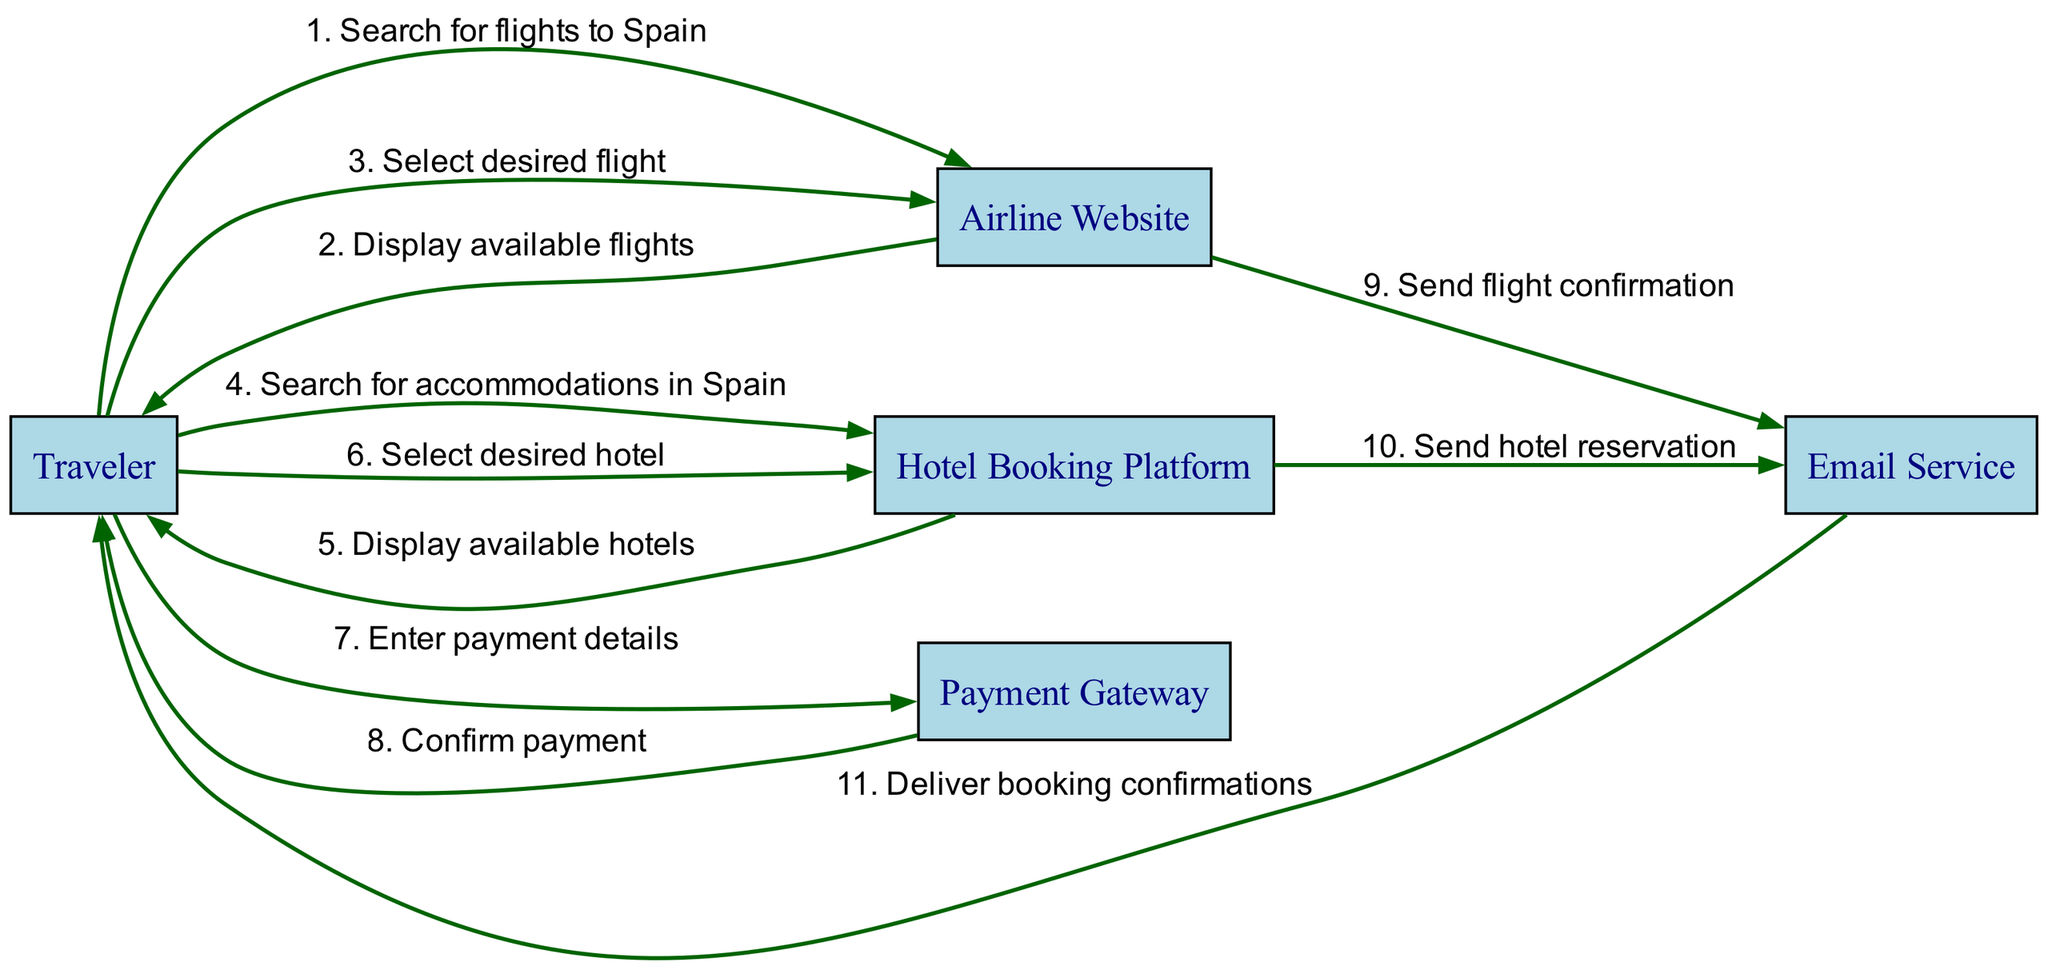What is the first action taken by the Traveler? The first action taken by the Traveler is to search for flights to Spain. This is explicitly indicated as the first action in the sequence diagram, where the Traveler interacts with the Airline Website.
Answer: Search for flights to Spain How many total actors are present in the diagram? The diagram contains a total of five actors: Traveler, Airline Website, Hotel Booking Platform, Payment Gateway, and Email Service. This can be counted directly from the list of actors in the diagram.
Answer: Five What is the final action in the sequence? The final action involves the Email Service delivering the booking confirmations to the Traveler. By following the sequence from start to finish, this action appears last in the process flow.
Answer: Deliver booking confirmations Which actor is responsible for sending the flight confirmation? The actor responsible for sending the flight confirmation is the Email Service. This is shown in the interaction between the Airline Website and the Email Service that follows the payment confirmation.
Answer: Email Service What happens after the Traveler enters payment details? After the Traveler enters payment details, the Payment Gateway confirms the payment. This sequential relationship shows that an action by the Traveler leads directly to a response from the Payment Gateway.
Answer: Confirm payment How many actions occur between the Traveler and the Hotel Booking Platform? There are three actions that occur between the Traveler and the Hotel Booking Platform. The Traveler searches for accommodations, receives available hotels, and selects a hotel. These interactions can be counted from the specified actions concerning the Hotel Booking Platform.
Answer: Three What action is taken immediately before the Email Service sends the hotel reservation? The action taken immediately before the Email Service sends the hotel reservation is the Hotel Booking Platform sending the reservation information to the Email Service. This logical sequence illustrates the flow from hotel reservations to confirmations.
Answer: Send hotel reservation Which action follows the confirmation of payment? The action that follows the confirmation of payment is the Airline Website sending the flight confirmation to the Email Service. By tracing the flow, this action takes place right after payment is confirmed.
Answer: Send flight confirmation 